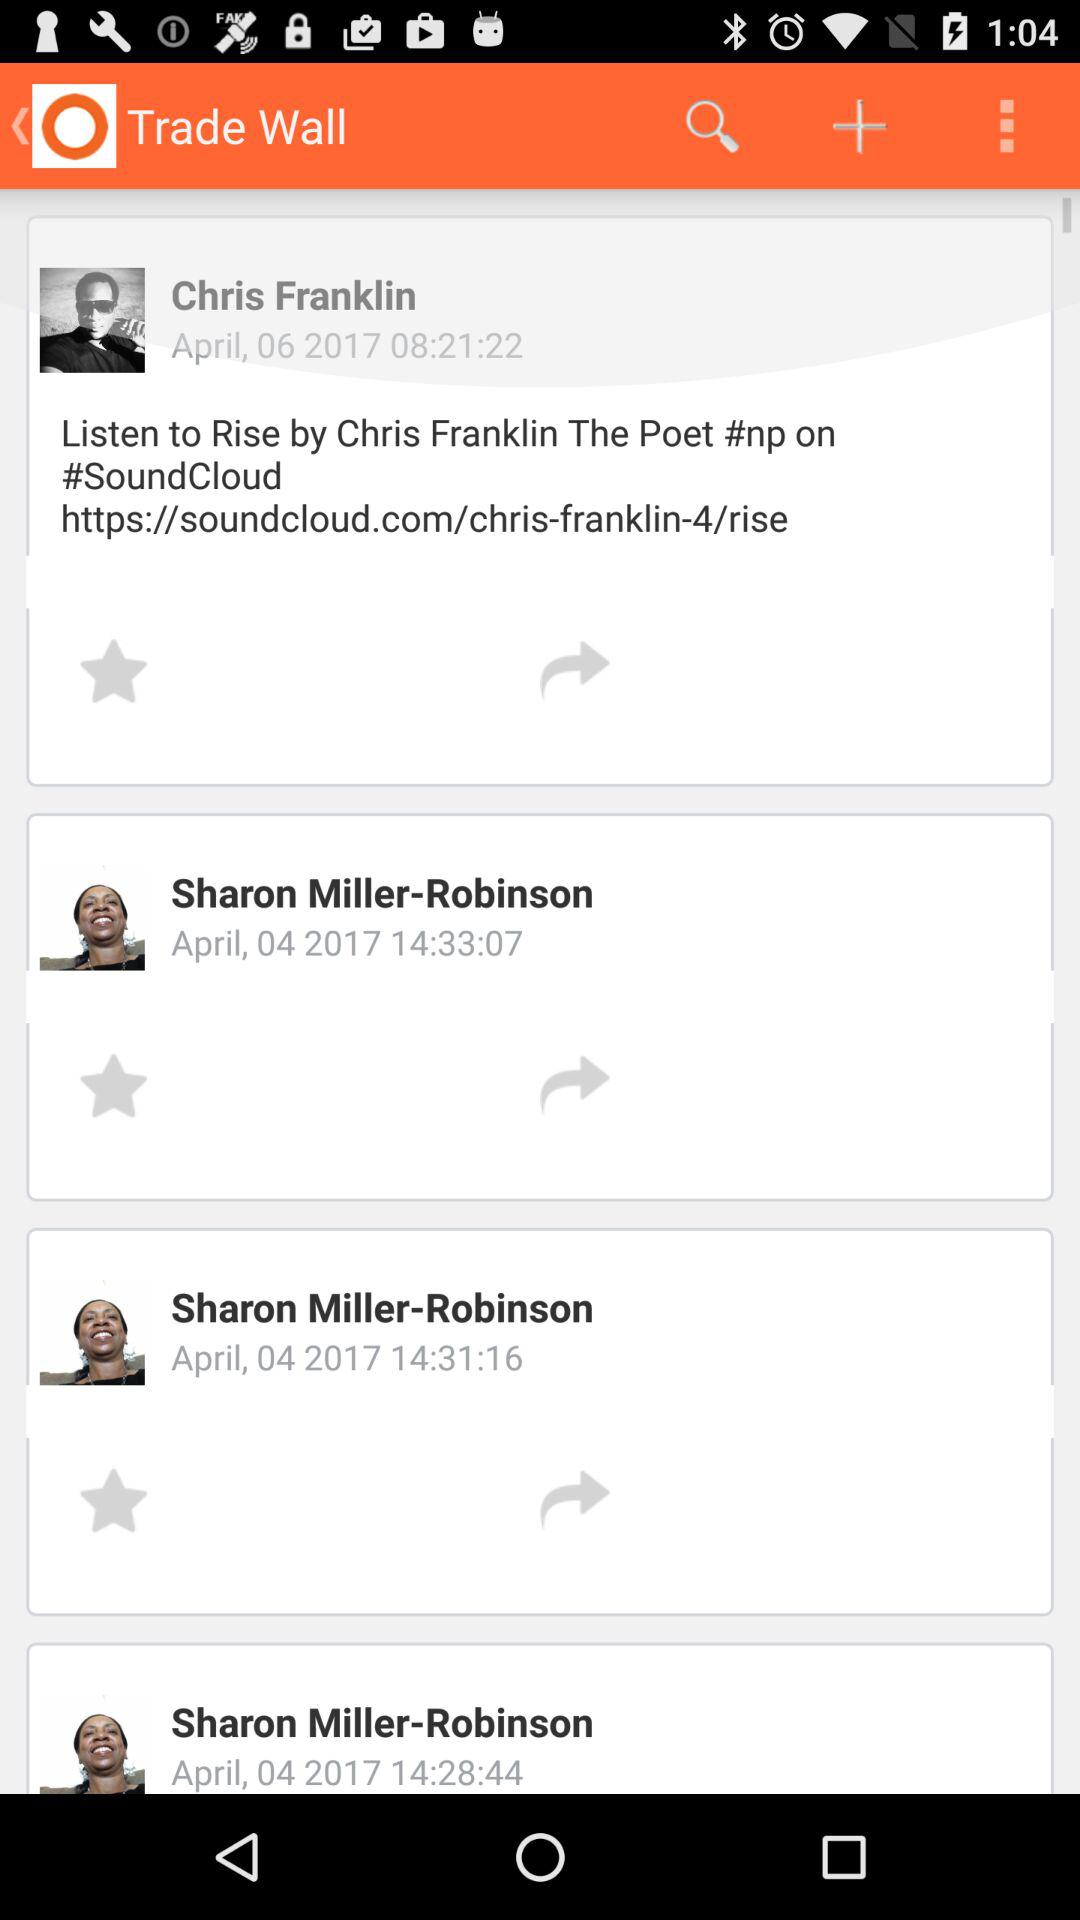How many items have the text 'Sharon Miller-Robinson'?
Answer the question using a single word or phrase. 3 